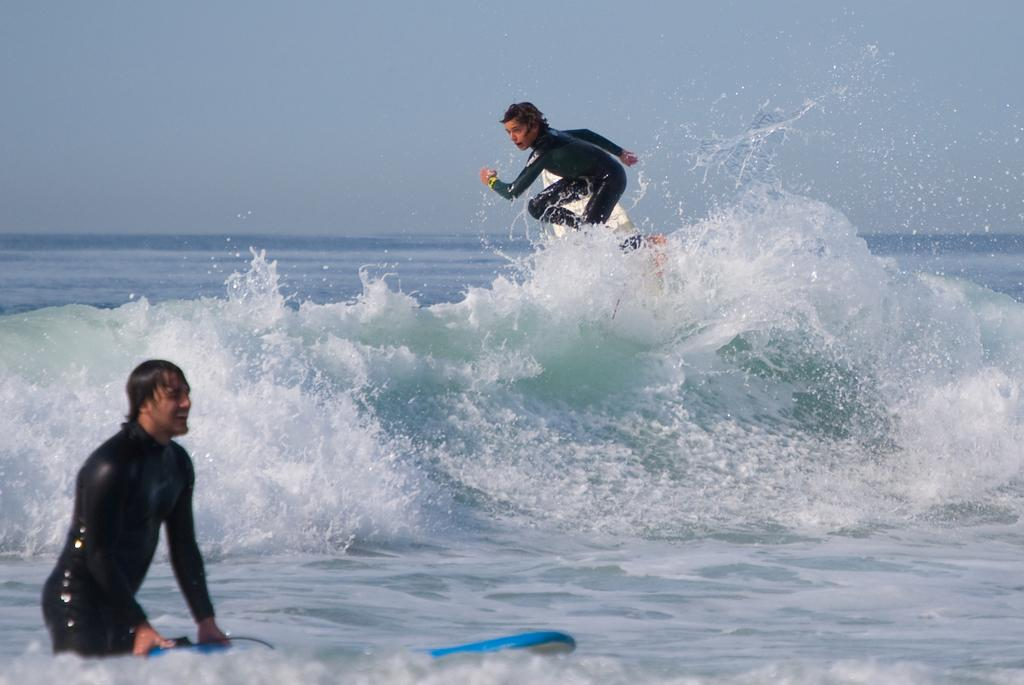How many people are in the image? There are two people in the image. What is one person doing in the image? One person is surfing on a surfing board. Where is the surfing taking place? The surfing is taking place on ocean tides. What can be seen in the background of the image? There is an ocean and the sky visible in the background of the image. Is the person surfing on a slope in the image? There is no slope present in the image; the surfing is taking place on ocean tides. Can you see the moon in the image? The moon is not visible in the image; only the sky is visible in the background. 